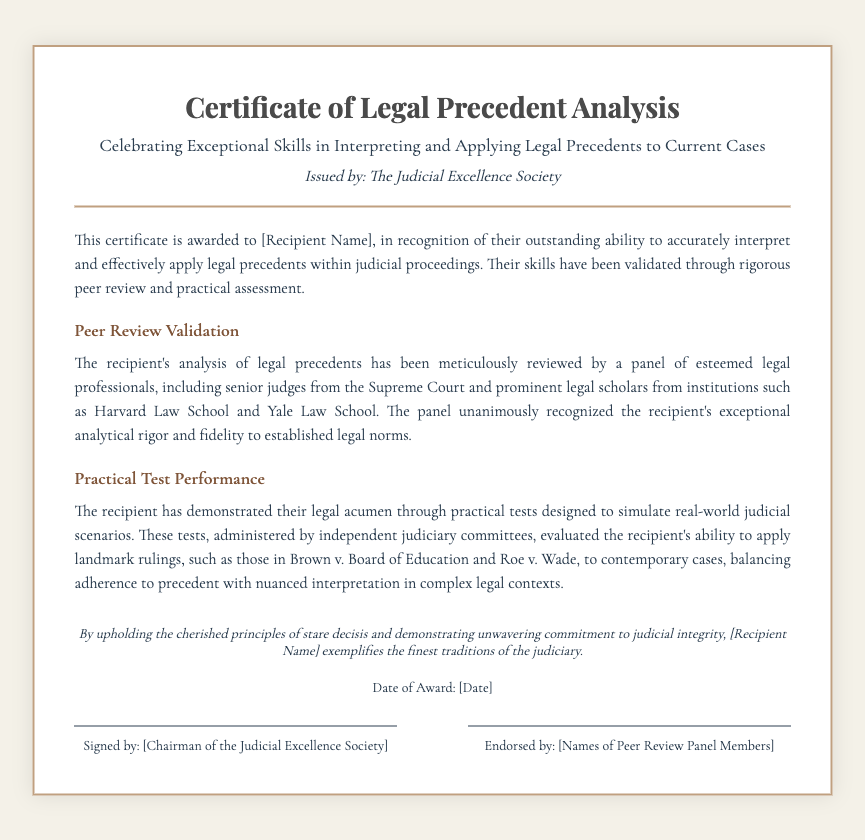What is the title of the certificate? The title of the certificate is stated at the top of the document, which is "Certificate of Legal Precedent Analysis."
Answer: Certificate of Legal Precedent Analysis Who issued the certificate? The entity that issued the certificate is mentioned in the header section, noted as "The Judicial Excellence Society."
Answer: The Judicial Excellence Society What is the purpose of this certificate? The purpose is described in the introductory section as recognizing the recipient's ability to interpret and apply legal precedents.
Answer: Recognizing exceptional skills What notable cases are mentioned in the practical test? The document references landmark rulings in the section describing practical test performance, including "Brown v. Board of Education" and "Roe v. Wade."
Answer: Brown v. Board of Education and Roe v. Wade Which esteemed institutions are mentioned in peer review? The institutions recognized in the peer review validation are "Harvard Law School" and "Yale Law School."
Answer: Harvard Law School and Yale Law School What is the date of award placeholder? The document contains a placeholder for the date of the award that is meant to be filled in, noted simply as "[Date]."
Answer: [Date] What does the recipient exemplify according to the remarks? The remarks section concludes with a statement about the recipient, specifically that they "exemplify the finest traditions of the judiciary."
Answer: The finest traditions of the judiciary Who signed the certificate? The footer indicates that the certificate was signed by the "Chairman of the Judicial Excellence Society."
Answer: Chairman of the Judicial Excellence Society What kind of professionals reviewed the peer analysis? The document specifies that the peer review was conducted by a "panel of esteemed legal professionals, including senior judges."
Answer: Senior judges 